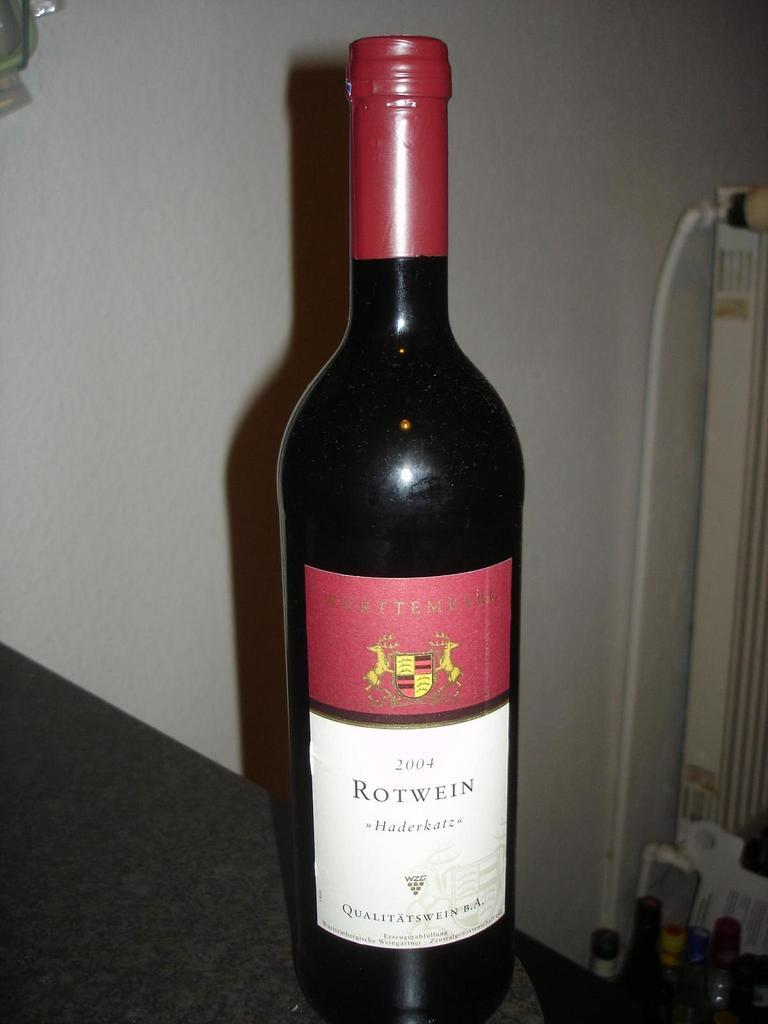What is written after rotwein?
Make the answer very short. Haderkatz. 